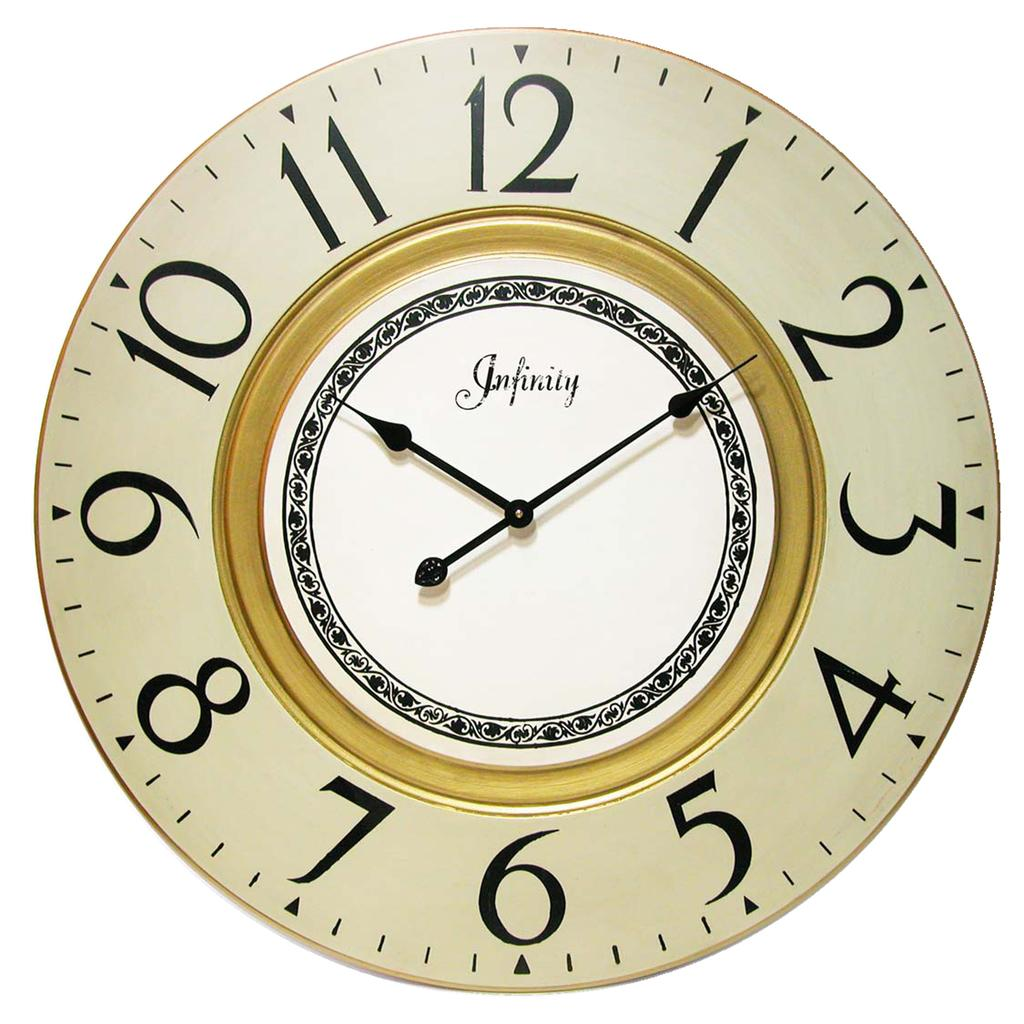<image>
Give a short and clear explanation of the subsequent image. A clock face that has the word infinity written on it. 